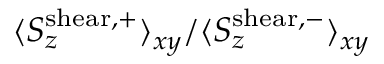<formula> <loc_0><loc_0><loc_500><loc_500>\langle S _ { z } ^ { s h e a r , + } \rangle _ { x y } / \langle S _ { z } ^ { s h e a r , - } \rangle _ { x y }</formula> 